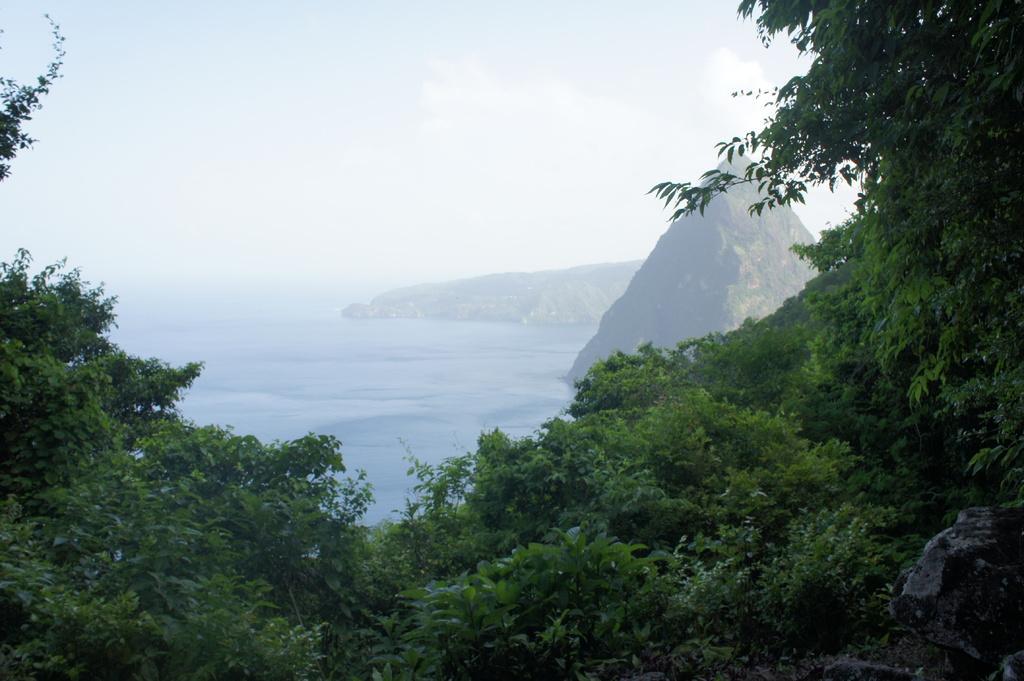Could you give a brief overview of what you see in this image? In this picture I can see trees. In the background I can see mountains, water and the sky. 